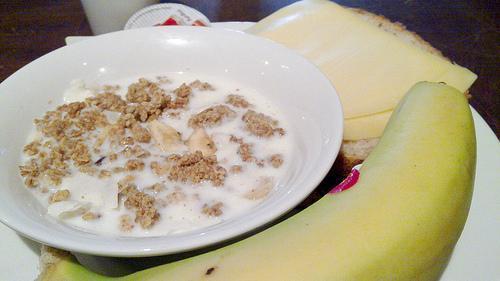How many banana's are there?
Give a very brief answer. 1. 